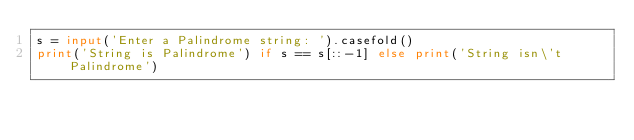Convert code to text. <code><loc_0><loc_0><loc_500><loc_500><_Python_>s = input('Enter a Palindrome string: ').casefold()
print('String is Palindrome') if s == s[::-1] else print('String isn\'t Palindrome')</code> 